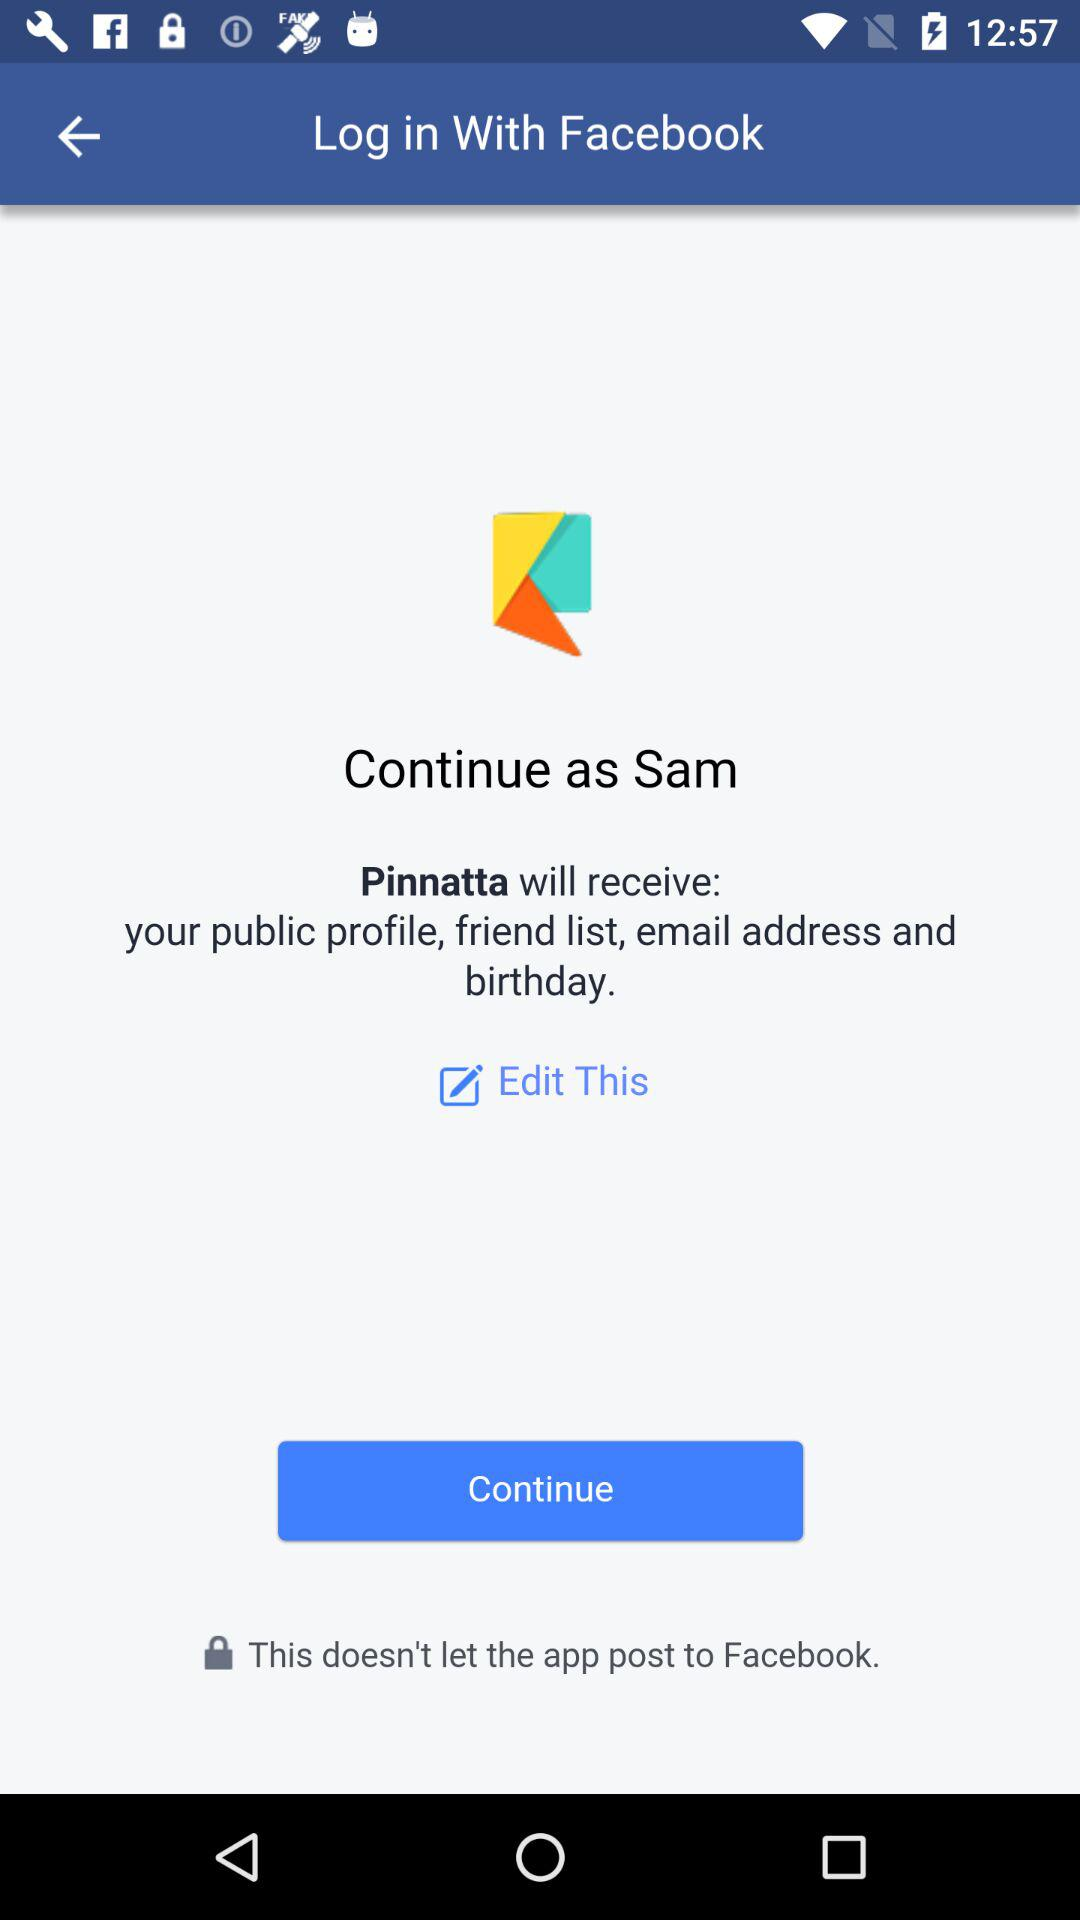Did the user edit this?
When the provided information is insufficient, respond with <no answer>. <no answer> 